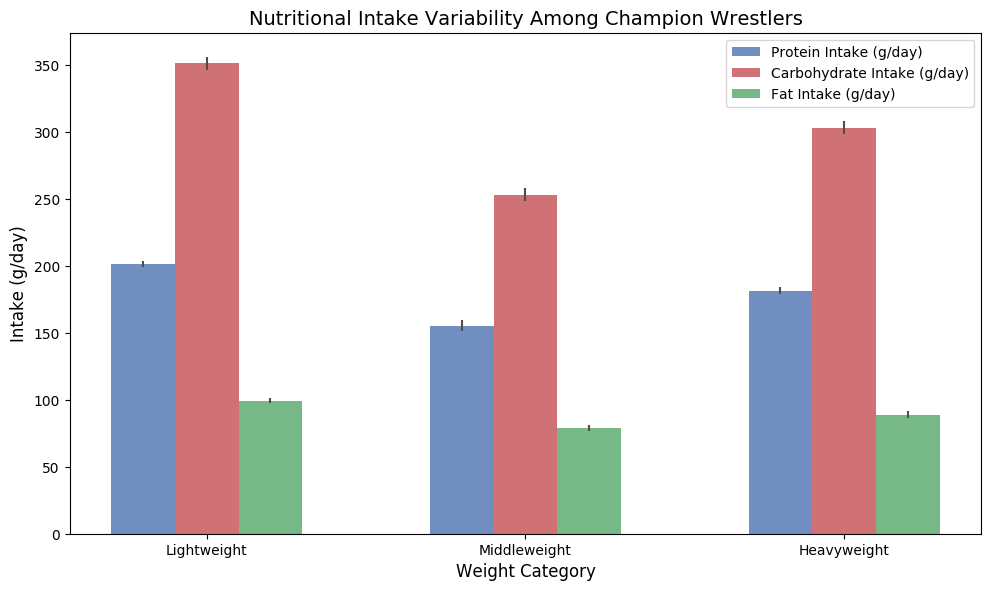What is the average Protein Intake (g/day) for Middleweight wrestlers? From the figure, locate the bar for Protein Intake within the Middleweight category. The label associated with this bar gives the mean Protein Intake (g/day) for this group.
Answer: 181 Which weight category has the highest variability in Carbohydrate Intake (g/day)? Look for the height of the error bars on the Carbohydrate Intake bars in each weight category. The category with the tallest error bar indicates the highest variability.
Answer: Heavyweight Compare the Fat Intake (g/day) between Lightweight and Middleweight wrestlers. Which category has higher average Fat Intake and by how much? Find the height of the bars for Fat Intake in both Lightweight and Middleweight categories. Subtract the average Fat Intake of the lower category from that of the higher category.
Answer: Middleweight, by approximately 10 g/day What’s the difference in average Protein Intake between Lightweight and Heavyweight categories? Find and note the Protein Intake bar heights for the Lightweight and Heavyweight categories. Subtract the smaller value from the larger one to find the difference.
Answer: 48 Which nutrient shows the lowest intake variability among Heavyweight wrestlers, and how do you identify this? Observe the error bars for all three nutrients (Protein, Carbohydrates, Fat) in the Heavyweight category. The nutrient with the shortest error bar has the lowest variability.
Answer: Fat What is the range of Carbohydrate Intake (g/day) for Lightweight wrestlers? Find the bar representing Carbohydrate Intake in the Lightweight category and observe its height and error bar length. Subtract the error from the mean to get the minimum, and add the error to the mean to get the maximum.
Answer: 248 to 260 Which weight category shows the least variability in Protein Intake, and how is it identified visually? Look at the error bars for Protein Intake across all weight categories. The category with the shortest error bar has the least variability.
Answer: Lightweight How does the average Carbohydrate Intake (g/day) for Heavyweight wrestlers compare to the average for Middleweight wrestlers? Find the heights of the Carbohydrate Intake bars for both Heavyweight and Middleweight categories and compare them directly.
Answer: Heavyweight intake is higher by approximately 48 g/day Among all categories and nutrients, which specific nutrient and category combination has the highest mean intake? Compare the heights of all nutrient bars across all categories to pinpoint the highest bar.
Answer: Heavyweight Carbohydrate Intake Given the visual information, what nutrient appears to correlate most positively with Performance Score based on its trend? Compare the performance scores and nutrient intakes across weight categories and observe any consistent upward trend.
Answer: Protein Intake 